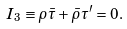<formula> <loc_0><loc_0><loc_500><loc_500>I _ { 3 } \equiv \rho \bar { \tau } + \bar { \rho } \tau ^ { \prime } = 0 .</formula> 